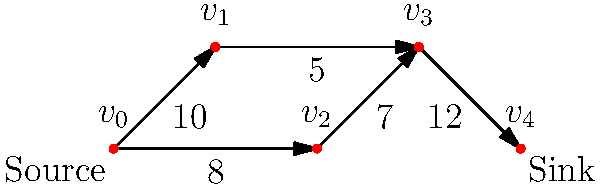In a digital art creation tool, you're implementing a fluid simulation feature using a maximum flow algorithm. The graph represents a simplified fluid network where vertices are junction points and edges are pipes with capacities (in units/second). What is the maximum flow from the source ($v_0$) to the sink ($v_4$) in this network? To find the maximum flow, we'll use the Ford-Fulkerson algorithm:

1. Initialize flow to 0.
2. Find an augmenting path from source to sink:
   a) Path: $v_0 \rightarrow v_1 \rightarrow v_3 \rightarrow v_4$, min capacity = 5
   b) Increase flow by 5, total flow = 5
3. Find another augmenting path:
   a) Path: $v_0 \rightarrow v_2 \rightarrow v_3 \rightarrow v_4$, min capacity = 7
   b) Increase flow by 7, total flow = 12
4. Find another augmenting path:
   a) Path: $v_0 \rightarrow v_1 \rightarrow v_3 \rightarrow v_4$, min residual capacity = 5
   b) Increase flow by 3 (limited by sink capacity), total flow = 15
5. No more augmenting paths exist.

The maximum flow is 15 units/second, which represents the maximum rate at which fluid can flow through this network in the digital art tool's simulation.
Answer: 15 units/second 